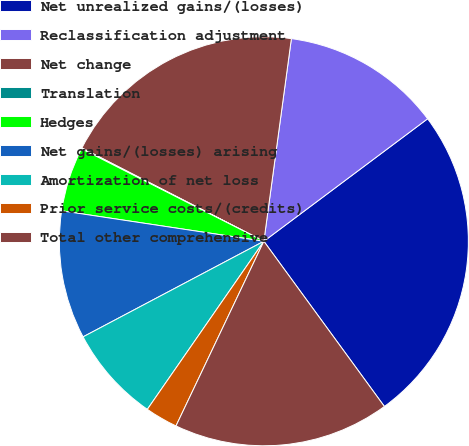<chart> <loc_0><loc_0><loc_500><loc_500><pie_chart><fcel>Net unrealized gains/(losses)<fcel>Reclassification adjustment<fcel>Net change<fcel>Translation<fcel>Hedges<fcel>Net gains/(losses) arising<fcel>Amortization of net loss<fcel>Prior service costs/(credits)<fcel>Total other comprehensive<nl><fcel>25.19%<fcel>12.63%<fcel>19.61%<fcel>0.07%<fcel>5.09%<fcel>10.12%<fcel>7.61%<fcel>2.58%<fcel>17.1%<nl></chart> 